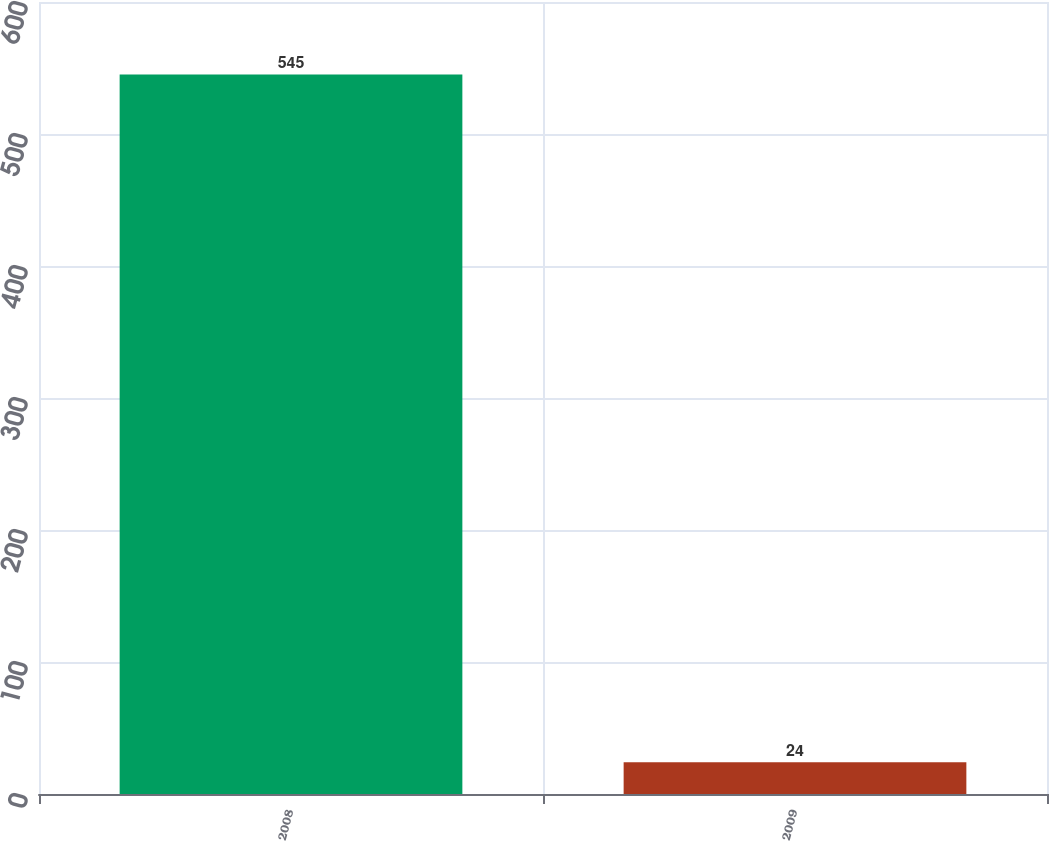<chart> <loc_0><loc_0><loc_500><loc_500><bar_chart><fcel>2008<fcel>2009<nl><fcel>545<fcel>24<nl></chart> 